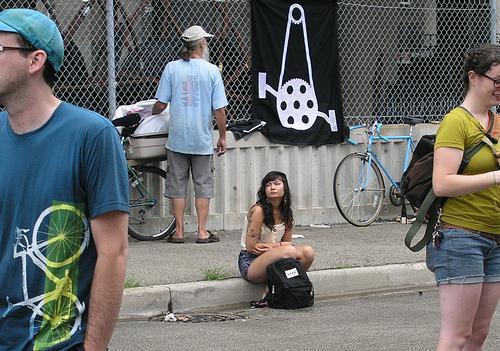How many women sitting?
Give a very brief answer. 1. 